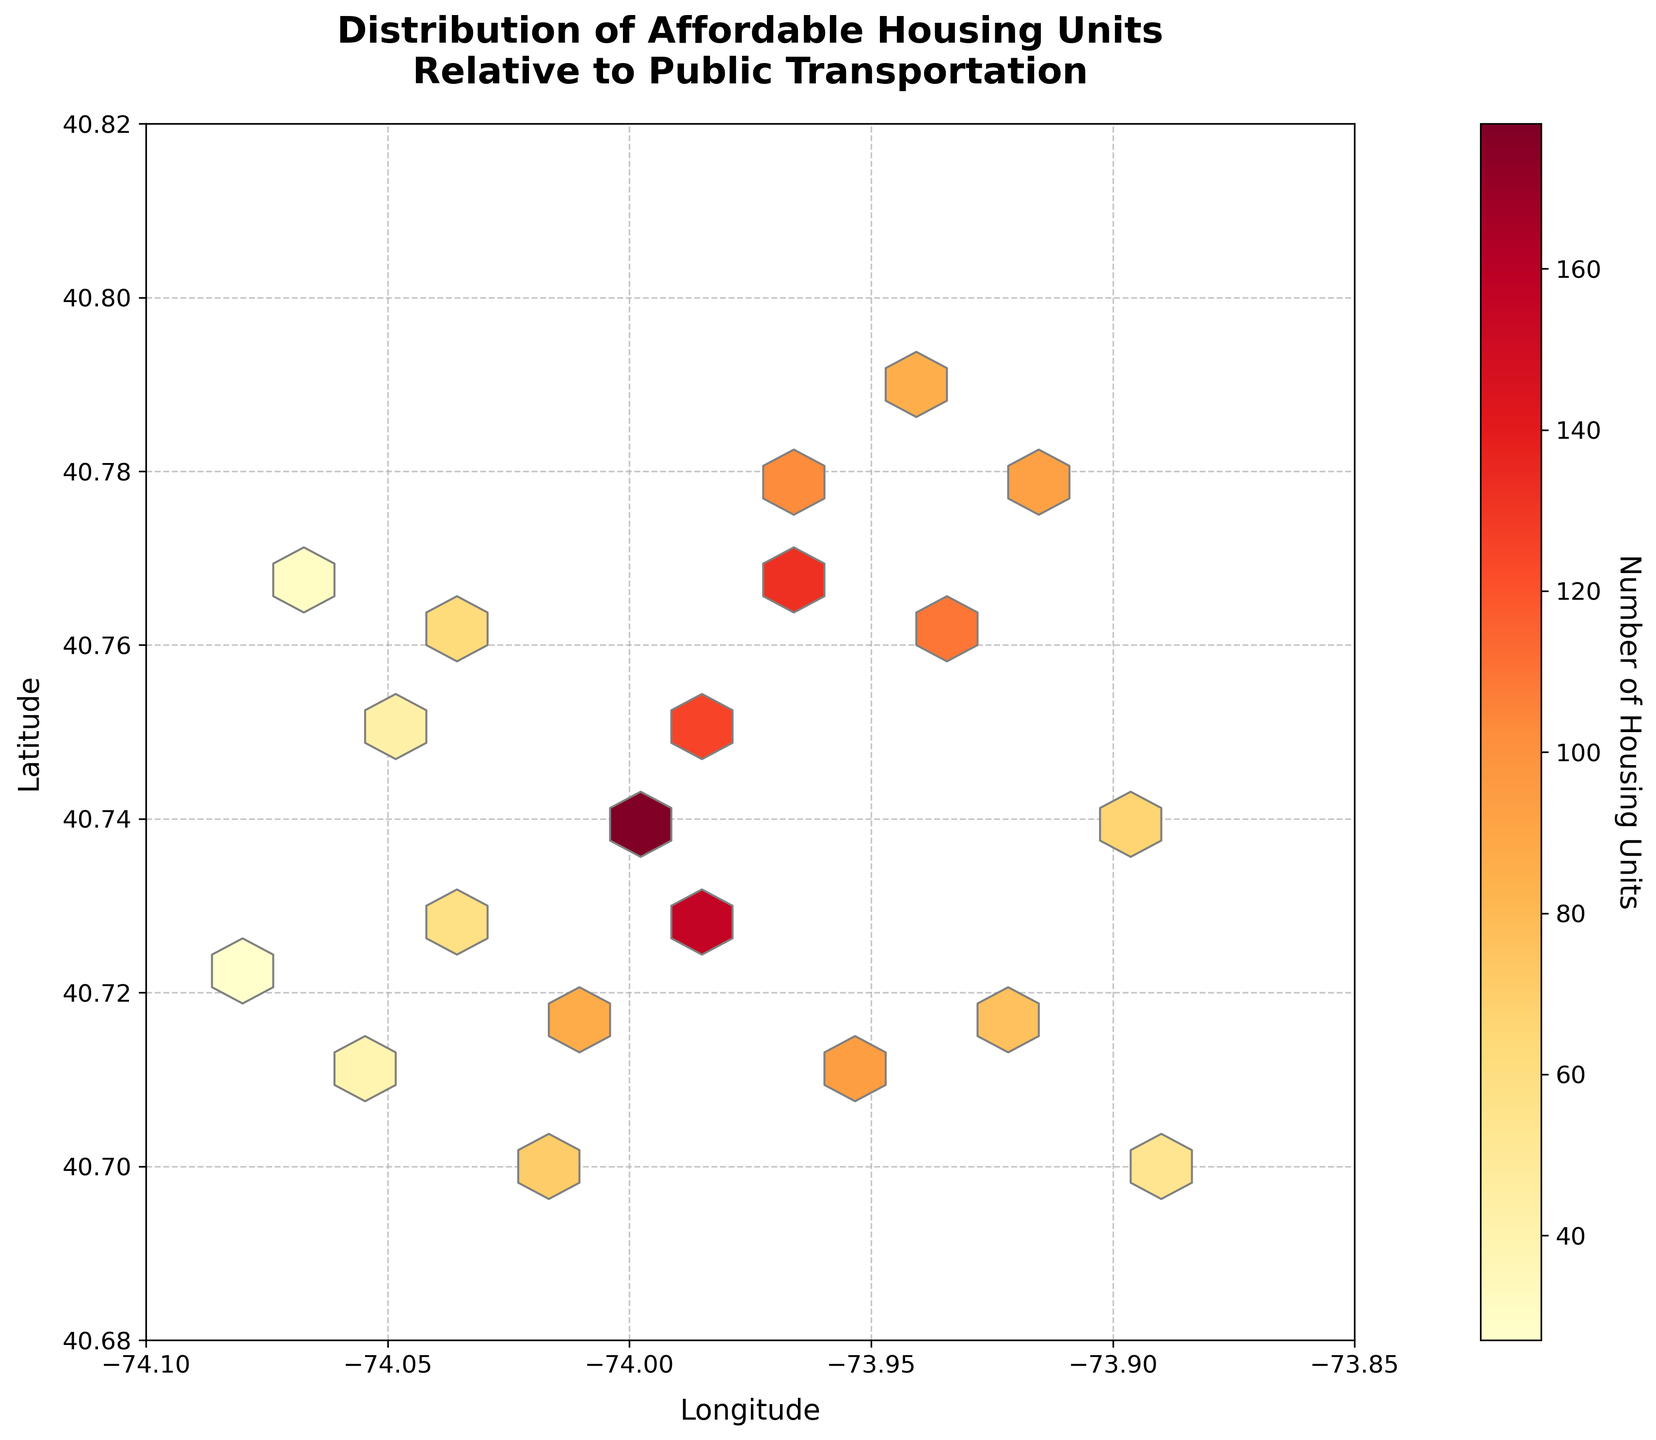What is the title of the plot? The title is usually located at the top of the plot and is labeled in bold and larger font compared to other text. It helps provide context for the figure.
Answer: Distribution of Affordable Housing Units Relative to Public Transportation What do the colors on the hexbin plot represent? In a hexbin plot, different colors indicate varying intensities of data points. The color bar to the right of the plot shows the range and corresponding values.
Answer: Number of Housing Units What are the axes labeled? The axes labels are usually found next to the axes and provide context about the variables being plotted. Here, the x-axis is labeled as longitude and the y-axis as latitude.
Answer: Longitude and Latitude How many main clusters of data can be observed? To determine the number of clusters, you look for groups of hexagons that are closely packed together and have similar color intensities.
Answer: Four main clusters Where is the highest concentration of affordable housing units located? Identify the hexbin with the darkest color, referring to the color bar to see the highest value. Locate this hexbin's position relative to the axes.
Answer: Around Longitude -74.00, Latitude 40.74 Is there a significant difference in the number of affordable housing units near longitude -74.00 and latitude 40.74 versus longitude -74.01 and latitude 40.72? Compare the color intensity and the corresponding number of units in these two locations using the color bar. The darker the color, the higher the unit count.
Answer: Yes, the location at Longitude -74.00 and Latitude 40.74 has significantly more units Which hexbin has the lowest number of affordable housing units? Look for the hexbin with the lightest color on the plot, which indicates the lowest density. Check its position relative to the axes.
Answer: Near Longitude -74.08, Latitude 40.72 How does the distribution of units change as you move from longitude -73.90 to -74.10? Observe the variation in color intensity along the range of longitudes mentioned. Notice if there is a trend of increasing or decreasing intensity.
Answer: Generally decreases What general trend can you observe in the distribution of affordable housing units in relation to latitude? Investigate if there's a noticeable pattern or cluster distribution that varies with changes in latitude, moving from the lowest to the highest latitude.
Answer: Clusters tend to be more frequent around Latitude 40.74 to 40.76 What does the grid size of 15 refer to in the context of a hexbin plot? The grid size in a hexbin plot determines the number of hexagons that tile the plot’s area, affecting the resolution of data density representation. Here, it specifies that the plot is divided into approximately 15 bins along each axis.
Answer: Number of hexagons along each axis 